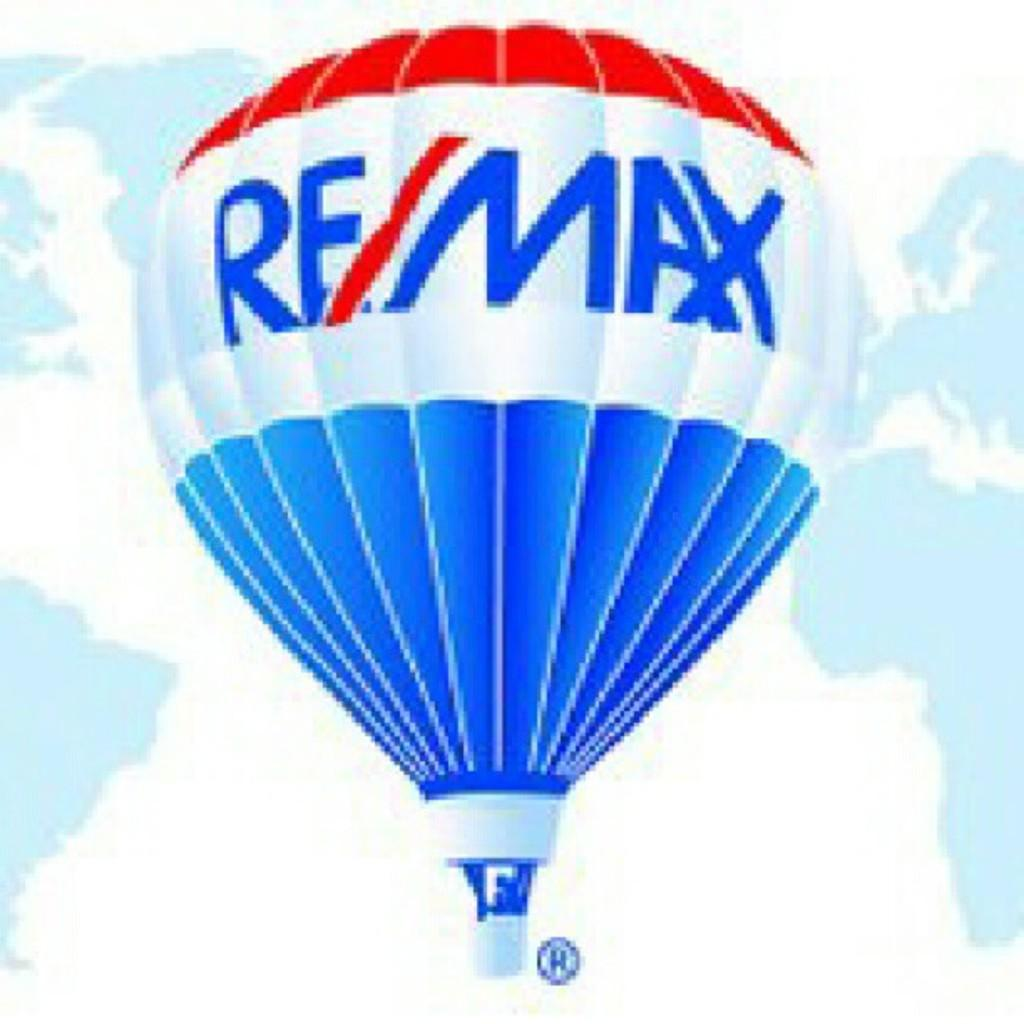What is the main object in the image? There is a parachute in the image. What colors are present on the parachute? The parachute has blue and red colors. What can be seen in the background of the image? The sky is visible in the background of the image. What colors are present in the sky? The sky has blue and white colors. What type of underwear is visible on the parachute in the image? There is no underwear present on the parachute in the image. What reason might someone have for using a parachute in the image? The image does not provide information about the reason for using the parachute, so it cannot be determined from the image. 